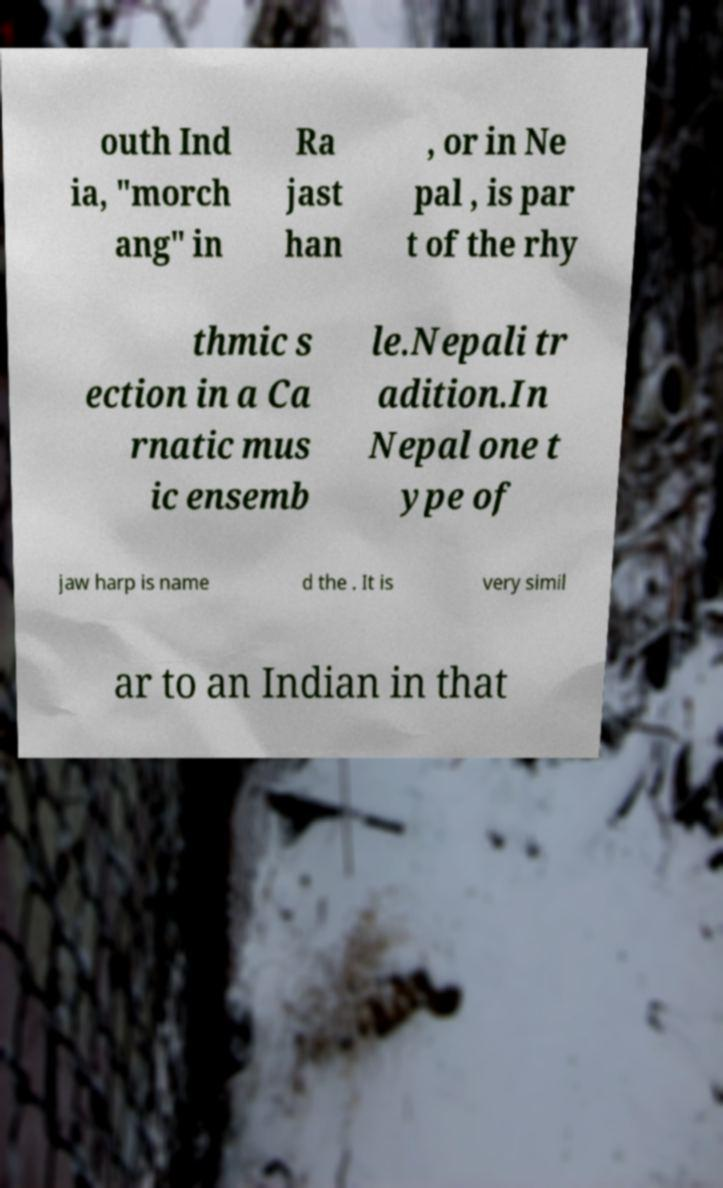I need the written content from this picture converted into text. Can you do that? outh Ind ia, "morch ang" in Ra jast han , or in Ne pal , is par t of the rhy thmic s ection in a Ca rnatic mus ic ensemb le.Nepali tr adition.In Nepal one t ype of jaw harp is name d the . It is very simil ar to an Indian in that 